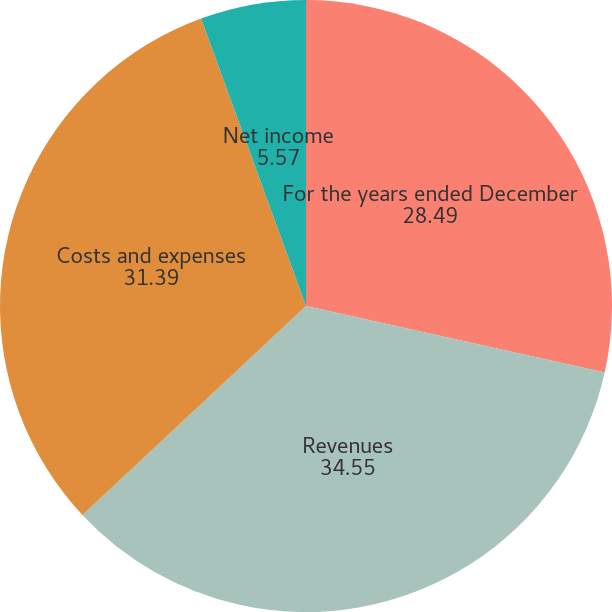<chart> <loc_0><loc_0><loc_500><loc_500><pie_chart><fcel>For the years ended December<fcel>Revenues<fcel>Costs and expenses<fcel>Net income<nl><fcel>28.49%<fcel>34.55%<fcel>31.39%<fcel>5.57%<nl></chart> 